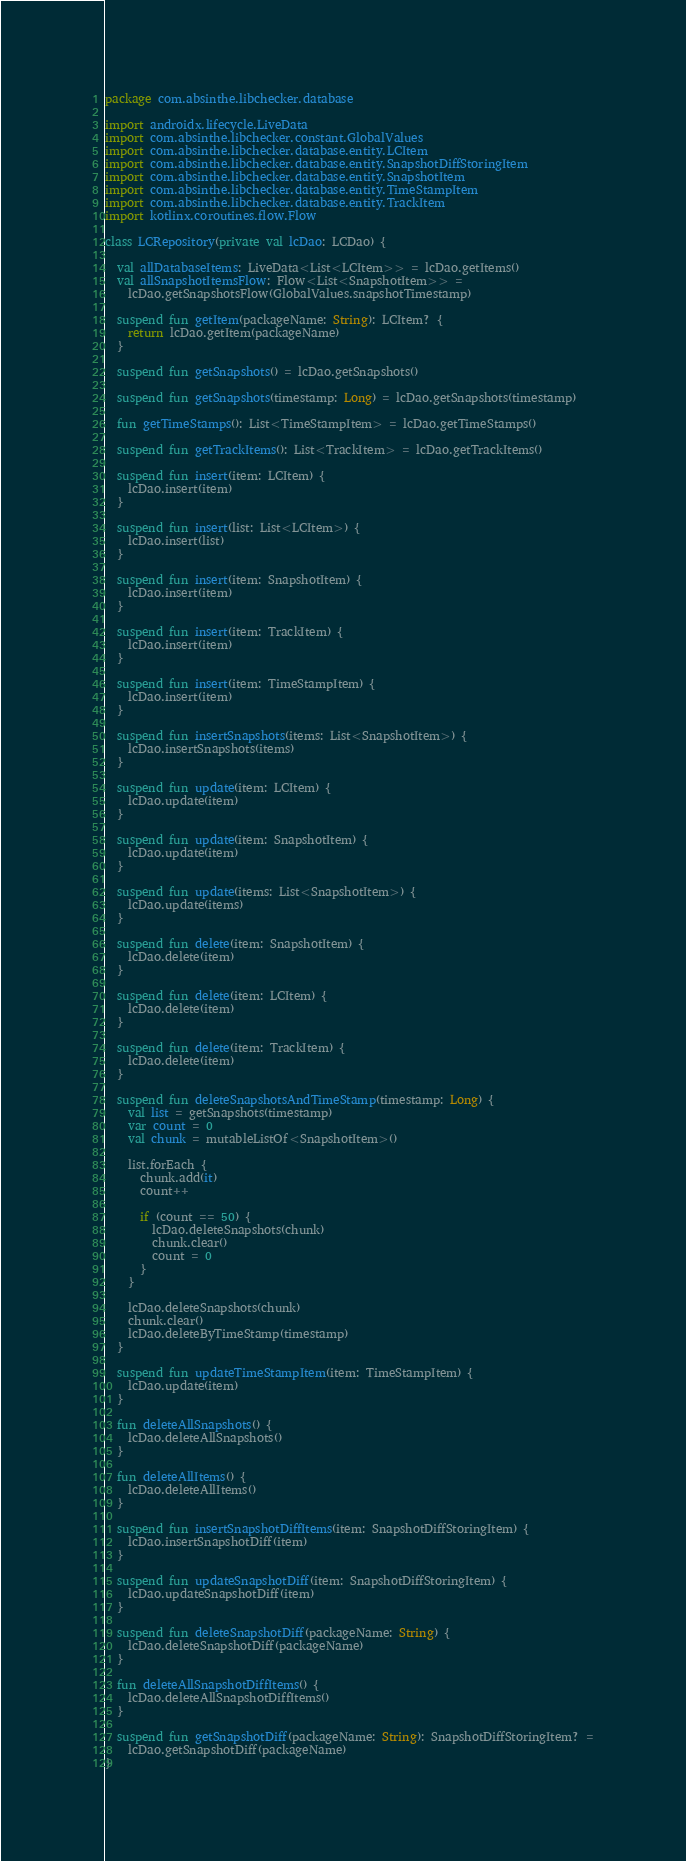<code> <loc_0><loc_0><loc_500><loc_500><_Kotlin_>package com.absinthe.libchecker.database

import androidx.lifecycle.LiveData
import com.absinthe.libchecker.constant.GlobalValues
import com.absinthe.libchecker.database.entity.LCItem
import com.absinthe.libchecker.database.entity.SnapshotDiffStoringItem
import com.absinthe.libchecker.database.entity.SnapshotItem
import com.absinthe.libchecker.database.entity.TimeStampItem
import com.absinthe.libchecker.database.entity.TrackItem
import kotlinx.coroutines.flow.Flow

class LCRepository(private val lcDao: LCDao) {

  val allDatabaseItems: LiveData<List<LCItem>> = lcDao.getItems()
  val allSnapshotItemsFlow: Flow<List<SnapshotItem>> =
    lcDao.getSnapshotsFlow(GlobalValues.snapshotTimestamp)

  suspend fun getItem(packageName: String): LCItem? {
    return lcDao.getItem(packageName)
  }

  suspend fun getSnapshots() = lcDao.getSnapshots()

  suspend fun getSnapshots(timestamp: Long) = lcDao.getSnapshots(timestamp)

  fun getTimeStamps(): List<TimeStampItem> = lcDao.getTimeStamps()

  suspend fun getTrackItems(): List<TrackItem> = lcDao.getTrackItems()

  suspend fun insert(item: LCItem) {
    lcDao.insert(item)
  }

  suspend fun insert(list: List<LCItem>) {
    lcDao.insert(list)
  }

  suspend fun insert(item: SnapshotItem) {
    lcDao.insert(item)
  }

  suspend fun insert(item: TrackItem) {
    lcDao.insert(item)
  }

  suspend fun insert(item: TimeStampItem) {
    lcDao.insert(item)
  }

  suspend fun insertSnapshots(items: List<SnapshotItem>) {
    lcDao.insertSnapshots(items)
  }

  suspend fun update(item: LCItem) {
    lcDao.update(item)
  }

  suspend fun update(item: SnapshotItem) {
    lcDao.update(item)
  }

  suspend fun update(items: List<SnapshotItem>) {
    lcDao.update(items)
  }

  suspend fun delete(item: SnapshotItem) {
    lcDao.delete(item)
  }

  suspend fun delete(item: LCItem) {
    lcDao.delete(item)
  }

  suspend fun delete(item: TrackItem) {
    lcDao.delete(item)
  }

  suspend fun deleteSnapshotsAndTimeStamp(timestamp: Long) {
    val list = getSnapshots(timestamp)
    var count = 0
    val chunk = mutableListOf<SnapshotItem>()

    list.forEach {
      chunk.add(it)
      count++

      if (count == 50) {
        lcDao.deleteSnapshots(chunk)
        chunk.clear()
        count = 0
      }
    }

    lcDao.deleteSnapshots(chunk)
    chunk.clear()
    lcDao.deleteByTimeStamp(timestamp)
  }

  suspend fun updateTimeStampItem(item: TimeStampItem) {
    lcDao.update(item)
  }

  fun deleteAllSnapshots() {
    lcDao.deleteAllSnapshots()
  }

  fun deleteAllItems() {
    lcDao.deleteAllItems()
  }

  suspend fun insertSnapshotDiffItems(item: SnapshotDiffStoringItem) {
    lcDao.insertSnapshotDiff(item)
  }

  suspend fun updateSnapshotDiff(item: SnapshotDiffStoringItem) {
    lcDao.updateSnapshotDiff(item)
  }

  suspend fun deleteSnapshotDiff(packageName: String) {
    lcDao.deleteSnapshotDiff(packageName)
  }

  fun deleteAllSnapshotDiffItems() {
    lcDao.deleteAllSnapshotDiffItems()
  }

  suspend fun getSnapshotDiff(packageName: String): SnapshotDiffStoringItem? =
    lcDao.getSnapshotDiff(packageName)
}
</code> 